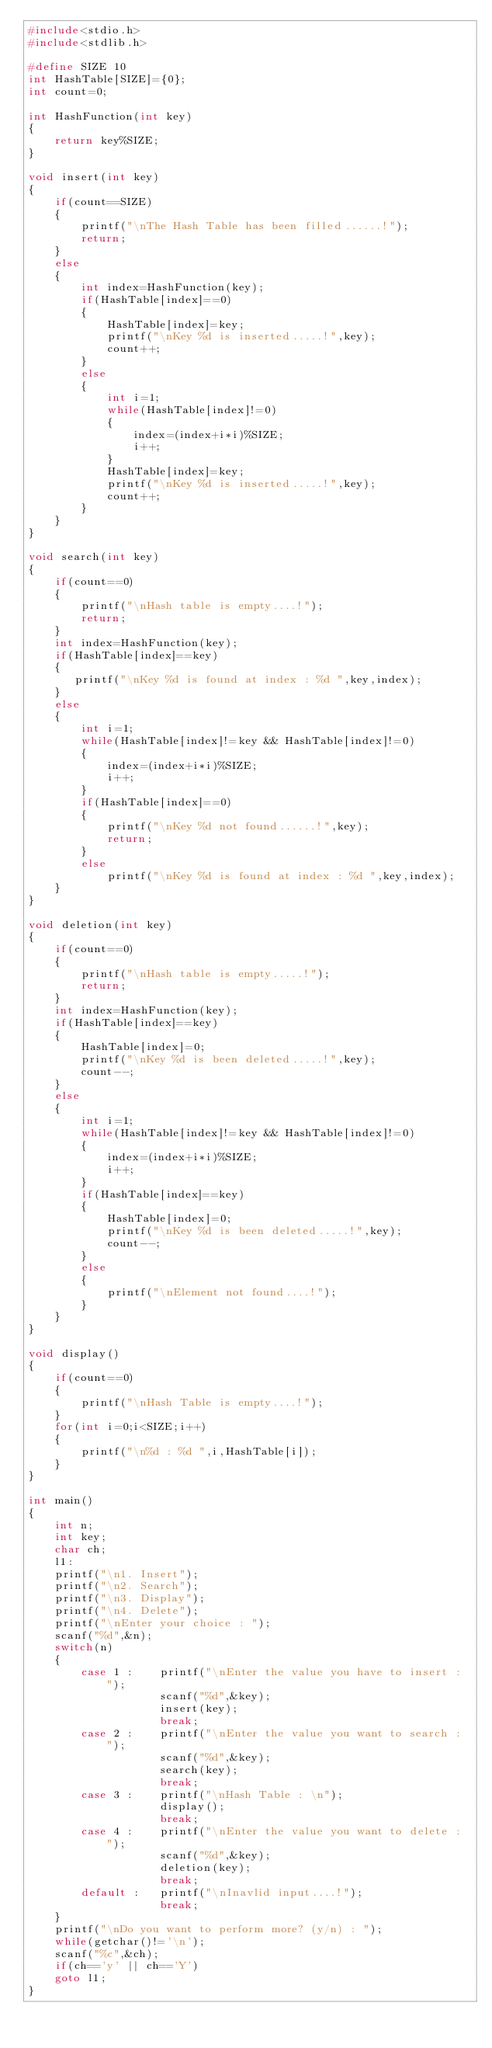Convert code to text. <code><loc_0><loc_0><loc_500><loc_500><_C_>#include<stdio.h>
#include<stdlib.h>

#define SIZE 10
int HashTable[SIZE]={0};
int count=0;

int HashFunction(int key)
{
    return key%SIZE;
}

void insert(int key)
{
    if(count==SIZE)
    {
        printf("\nThe Hash Table has been filled......!");
        return;
    }
    else
    {
        int index=HashFunction(key);
        if(HashTable[index]==0)
        {
            HashTable[index]=key;
            printf("\nKey %d is inserted.....!",key);
            count++;
        }
        else
        {
            int i=1;
            while(HashTable[index]!=0)
            {
                index=(index+i*i)%SIZE;
                i++;
            }
            HashTable[index]=key;
            printf("\nKey %d is inserted.....!",key);
            count++;
        }
    }
}

void search(int key)
{
    if(count==0)
    {
        printf("\nHash table is empty....!");
        return;
    }
    int index=HashFunction(key);
    if(HashTable[index]==key)
    {
       printf("\nKey %d is found at index : %d ",key,index);
    }
    else
    {
        int i=1;
        while(HashTable[index]!=key && HashTable[index]!=0)
        {
            index=(index+i*i)%SIZE;
            i++;
        }
        if(HashTable[index]==0)
        {
            printf("\nKey %d not found......!",key);
            return;
        }
        else
            printf("\nKey %d is found at index : %d ",key,index);
    }
}

void deletion(int key)
{
    if(count==0)
    {
        printf("\nHash table is empty.....!");
        return;
    }
    int index=HashFunction(key);
    if(HashTable[index]==key)
    {
        HashTable[index]=0;
        printf("\nKey %d is been deleted.....!",key);
        count--;
    }
    else
    {
        int i=1;
        while(HashTable[index]!=key && HashTable[index]!=0)
        {
            index=(index+i*i)%SIZE;
            i++;
        }
        if(HashTable[index]==key)
        {
            HashTable[index]=0;
            printf("\nKey %d is been deleted.....!",key);
            count--;
        }
        else
        {
            printf("\nElement not found....!");
        }
    }
}

void display()
{
    if(count==0)
    {
        printf("\nHash Table is empty....!");
    }
    for(int i=0;i<SIZE;i++)
    {
        printf("\n%d : %d ",i,HashTable[i]);
    }
}

int main()
{ 
    int n;
    int key;
    char ch;
    l1:
    printf("\n1. Insert");
    printf("\n2. Search");
    printf("\n3. Display");
    printf("\n4. Delete");
    printf("\nEnter your choice : ");
    scanf("%d",&n);
    switch(n)
    {
        case 1 :    printf("\nEnter the value you have to insert : ");
                    scanf("%d",&key);
                    insert(key);
                    break;
        case 2 :    printf("\nEnter the value you want to search : ");
                    scanf("%d",&key);
                    search(key);
                    break;
        case 3 :    printf("\nHash Table : \n");
                    display();
                    break;
        case 4 :    printf("\nEnter the value you want to delete : ");
                    scanf("%d",&key);
                    deletion(key);
                    break;
        default :   printf("\nInavlid input....!");
                    break;
    }
    printf("\nDo you want to perform more? (y/n) : ");
    while(getchar()!='\n');
    scanf("%c",&ch);
    if(ch=='y' || ch=='Y')
    goto l1;
}</code> 